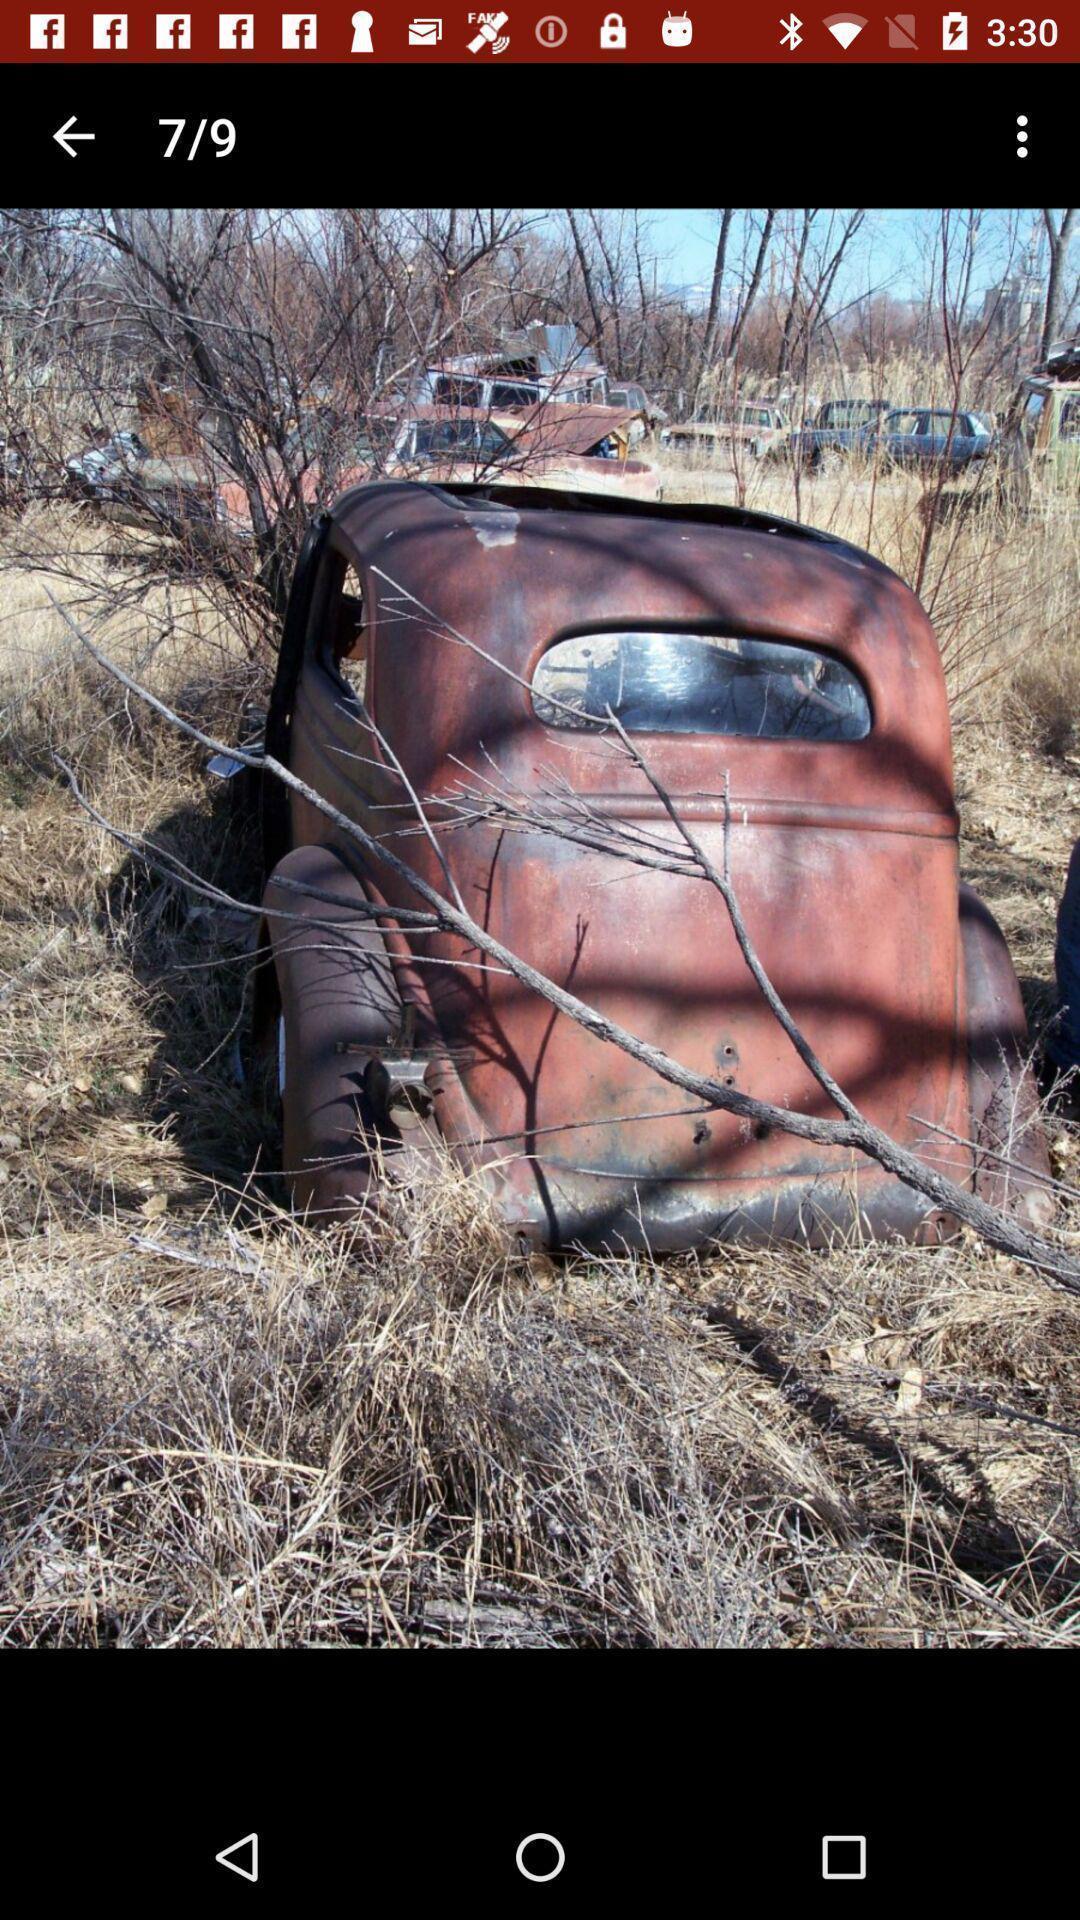Give me a summary of this screen capture. Screen shows a picture from a gallery. 